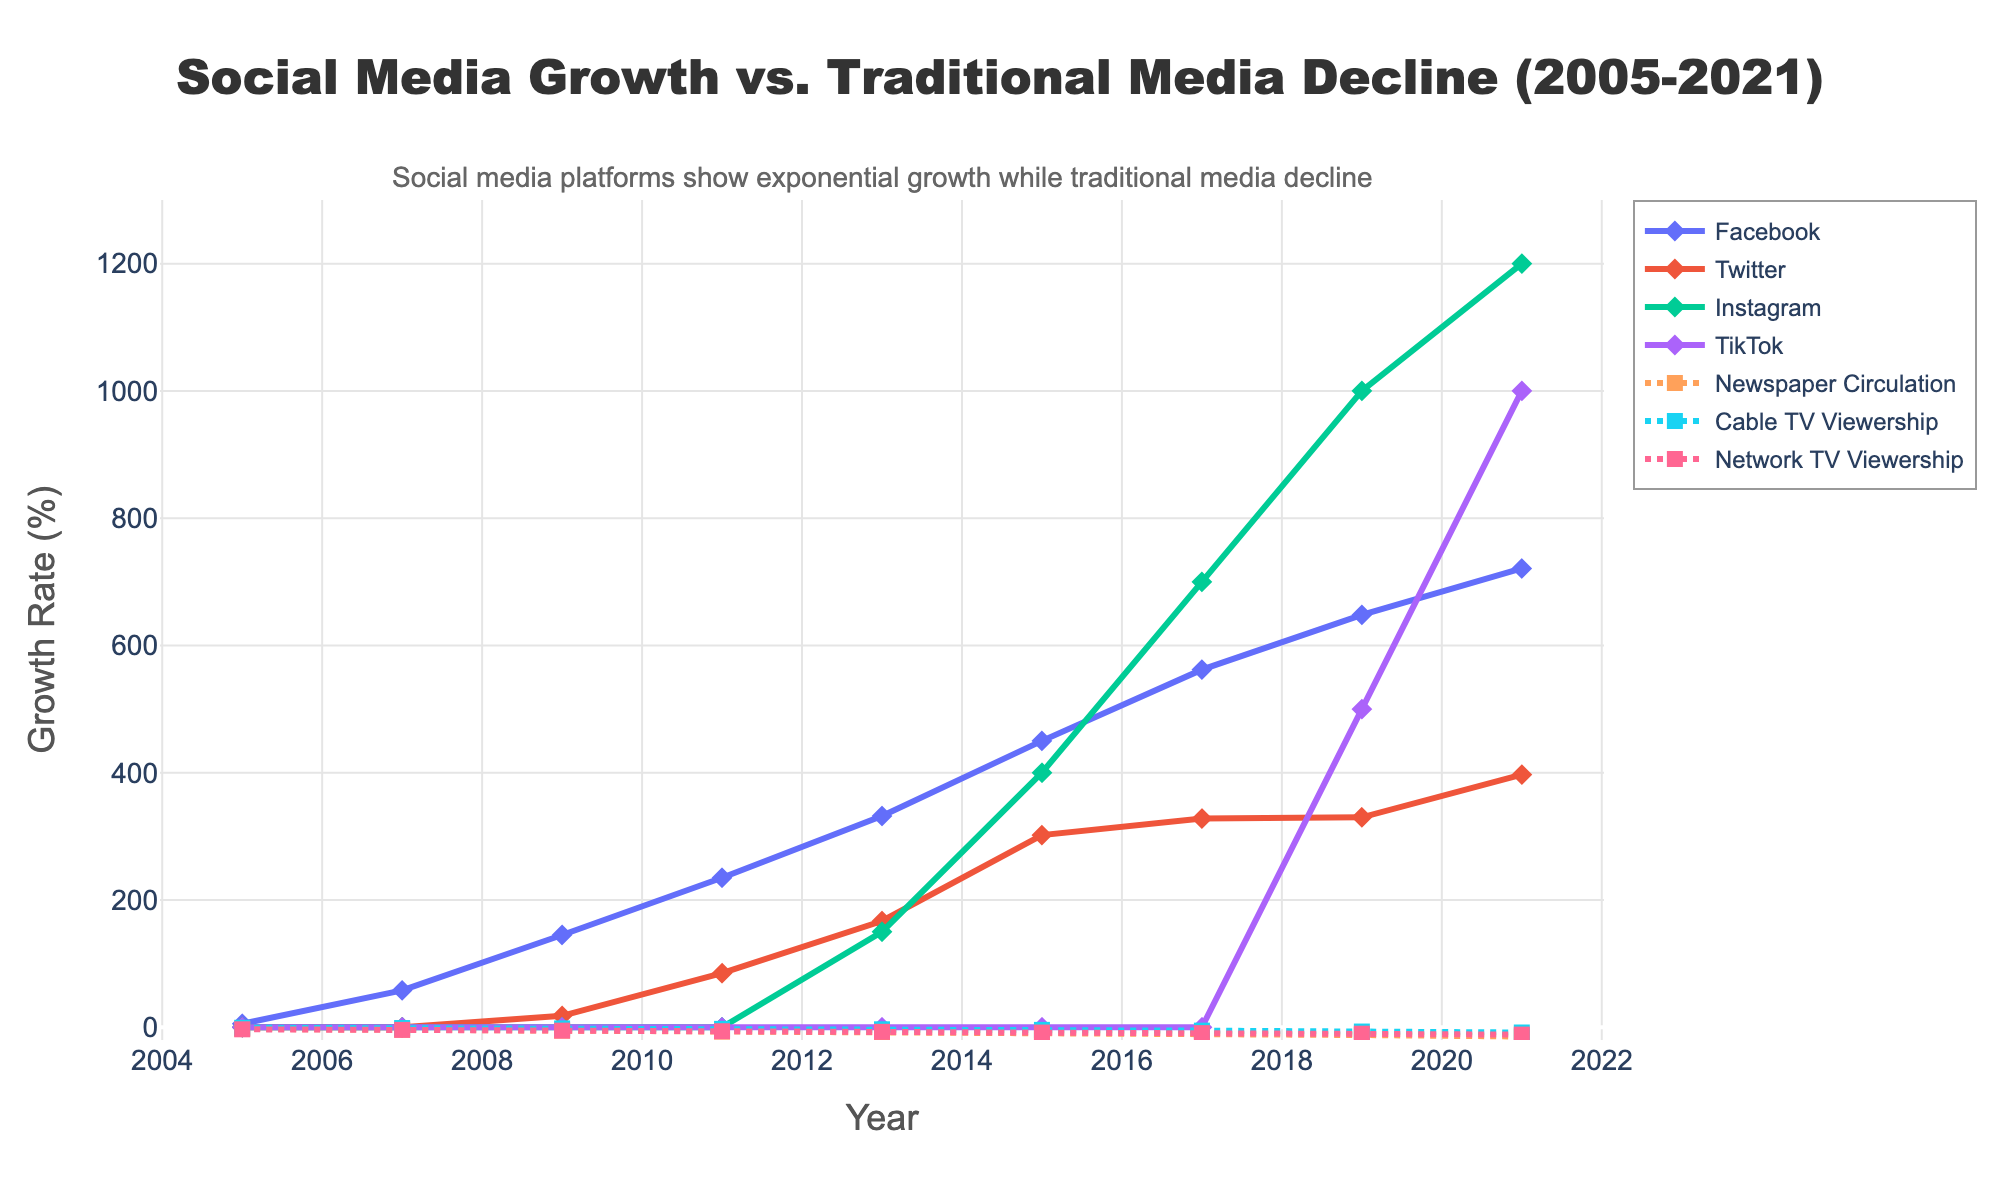What is the growth rate of Facebook in 2021 compared to 2005? The growth rate of Facebook in 2005 is 5.5%, and in 2021, it is 721%. To determine the increase, subtract 5.5 from 721.
Answer: 715.5 Which social media platform had the highest growth rate in 2021? By looking at the plotted lines for the year 2021, Instagram shows the highest growth rate at 1200%.
Answer: Instagram What is the difference in viewership decline between Cable TV and Network TV in 2015? In 2015, Cable TV viewership decline is -4.1%, and Network TV viewership decline is -8.3%. The difference is calculated as
Answer: 4.2 How does the growth rate of TikTok in 2019 compare to the growth rate of Twitter in 2015? In 2019, TikTok’s growth rate is 500%, while Twitter’s growth rate in 2015 is 302%. Thus, TikTok’s growth rate is higher by 198%.
Answer: TikTok is 198% higher What can you infer about the trend of traditional media viewership from 2005 to 2021? All traditional media (Newspaper Circulation, Cable TV Viewership, Network TV Viewership) show a consistent downward trend from 2005 to 2021.
Answer: Consistent decline In which year did Facebook experience the highest growth rate increase compared to the previous year, and what was the increase? Facebook saw the most significant growth rate increase from 2005 to 2007, rising from 5.5% to 58%. The increase is calculated as 58 - 5.5.
Answer: 2007, 52.5 Compare the growth rates of Instagram and TikTok in 2021. In 2021, Instagram's growth rate is 1200%, while TikTok's growth rate is 1000%. To compare, Instagram is 200% higher than TikTok.
Answer: Instagram is 200% higher By what percentage did Newspaper Circulation decline between 2005 and 2021? Newspaper Circulation declined from -2.5% in 2005 to -14.5% in 2021. Calculate the percentage difference: -14.5 - (-2.5).
Answer: 12 Which traditional media type has the least decline in viewership by 2021, and what is the percentage? By 2021, Cable TV Viewership has the least decline at -8.2% compared to Newspaper Circulation (-14.5%) and Network TV Viewership (-11.5%).
Answer: Cable TV, -8.2% What is the trend observed in social media platforms’ growth rates from 2017 to 2021? From 2017 to 2021, all social media platforms (Facebook, Twitter, Instagram, TikTok) show an upward trend, with TikTok experiencing the steepest growth.
Answer: Upward trend 